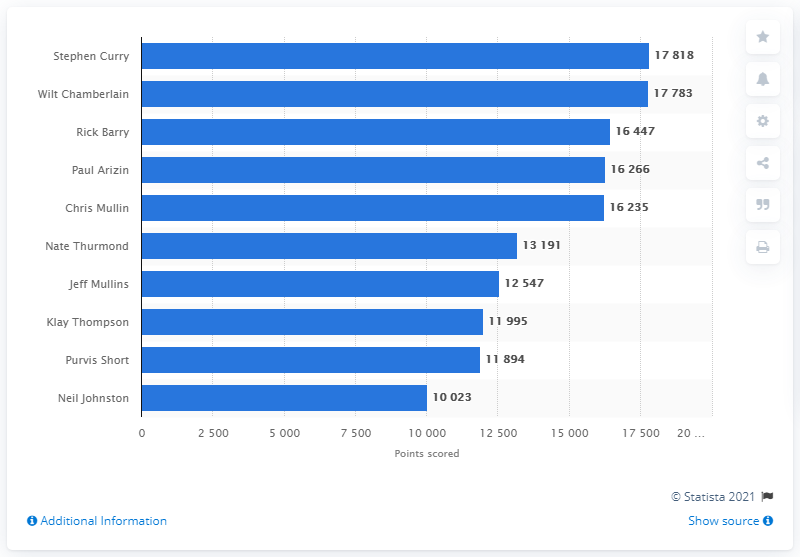Point out several critical features in this image. In April 2021, Stephen Curry became the career points leader of the Golden State Warriors. 